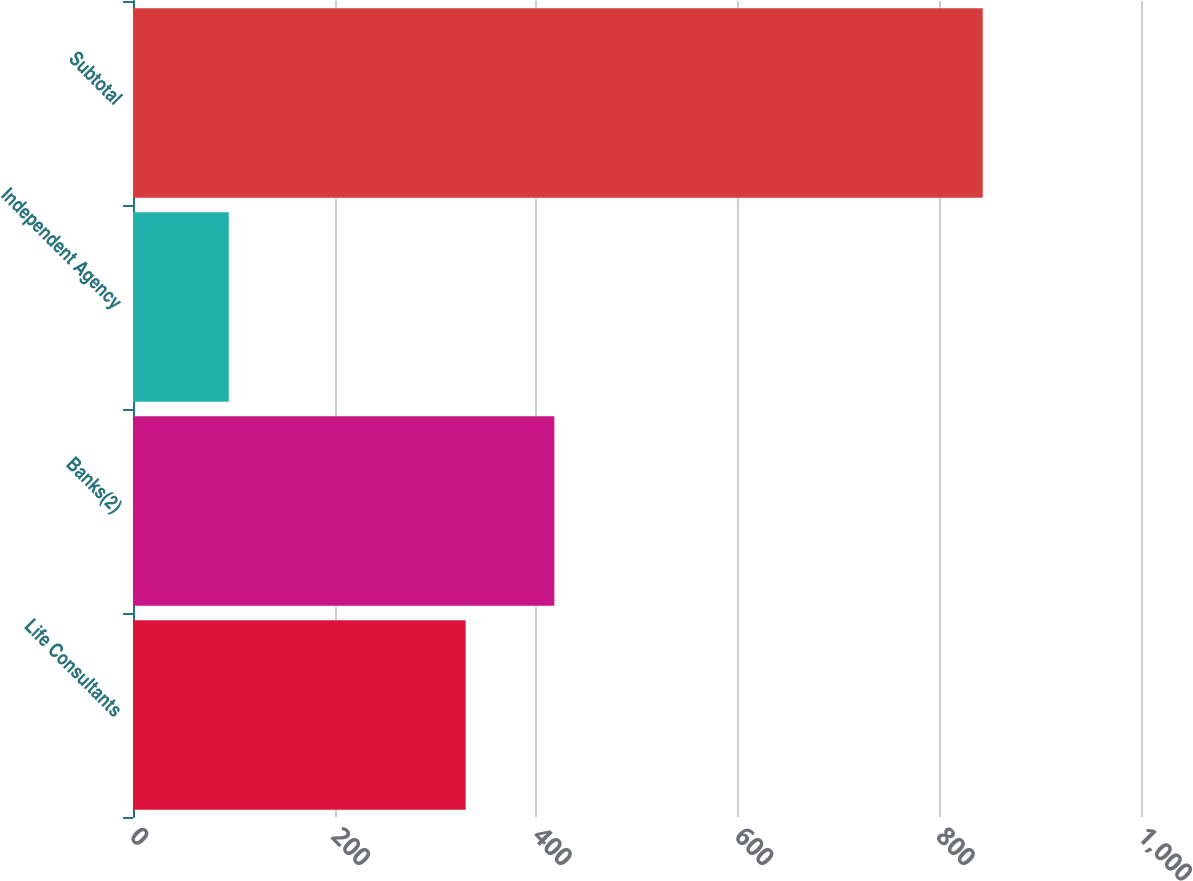Convert chart. <chart><loc_0><loc_0><loc_500><loc_500><bar_chart><fcel>Life Consultants<fcel>Banks(2)<fcel>Independent Agency<fcel>Subtotal<nl><fcel>330<fcel>418<fcel>95<fcel>843<nl></chart> 